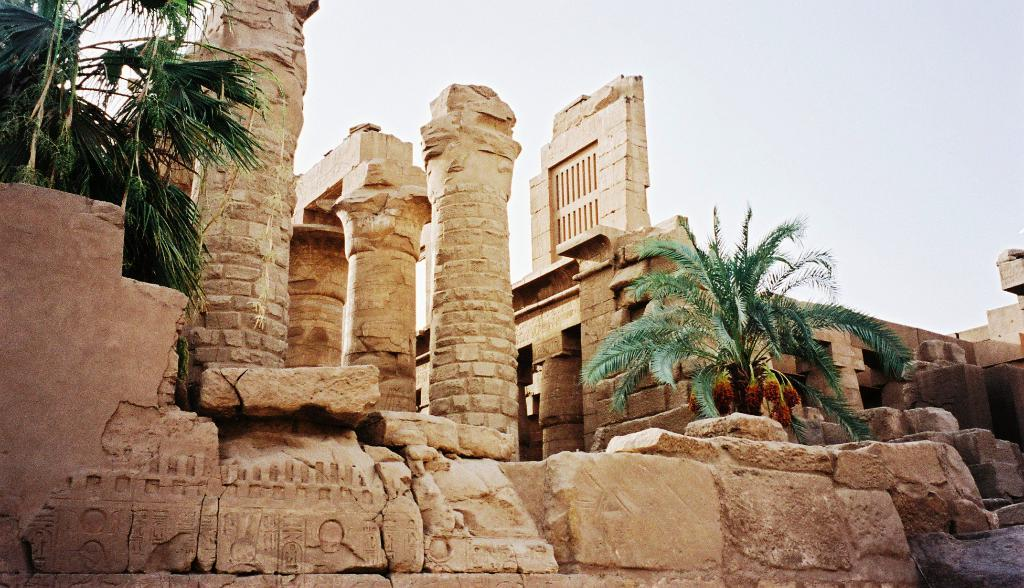What type of architecture is visible in the image? There is an ancient architecture in the image. What other elements can be seen in the image besides the architecture? There are trees in the image. What can be seen in the background of the image? The sky is visible in the background of the image. What type of rake is being used during the feast in the image? There is no rake or feast present in the image; it features ancient architecture and trees. 